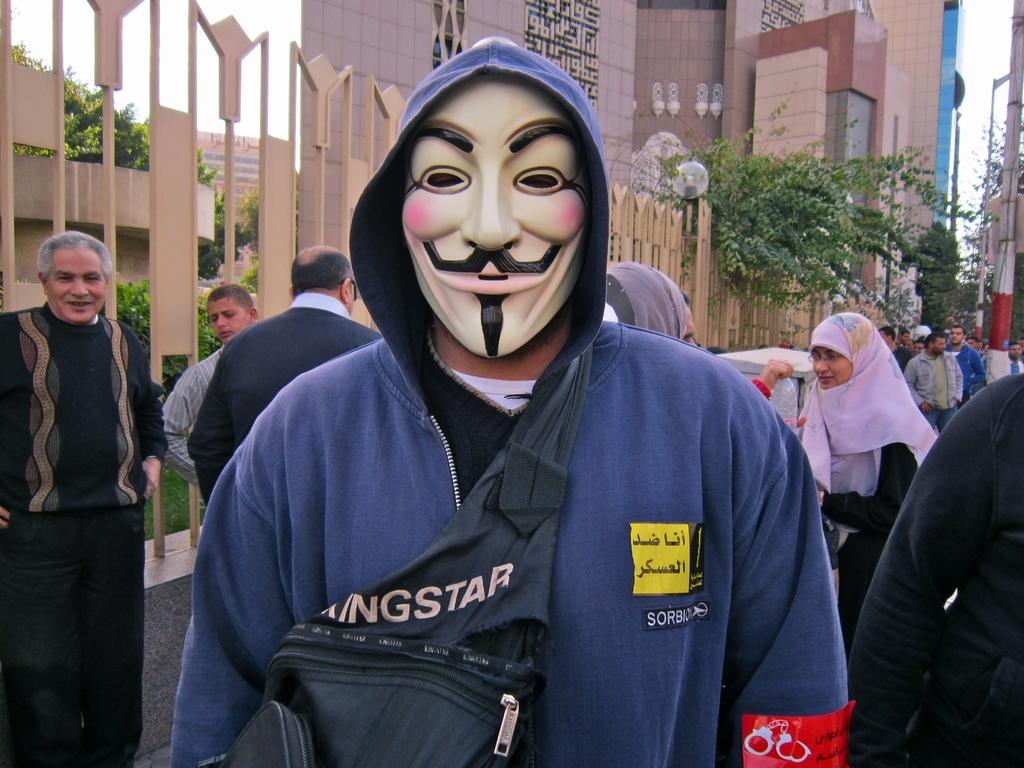How many people are in the image? There are people in the image, but the exact number is not specified. What can be seen in the background of the image? There are trees, buildings, and fencing visible in the image. What is visible in the sky in the image? The sky is visible in the image. What is one person wearing in the image? One person is wearing a mask in the image. What is one person carrying in the image? One person is carrying a bag in the image. How many bears are playing the quill in the image? There are no bears or quills present in the image. 